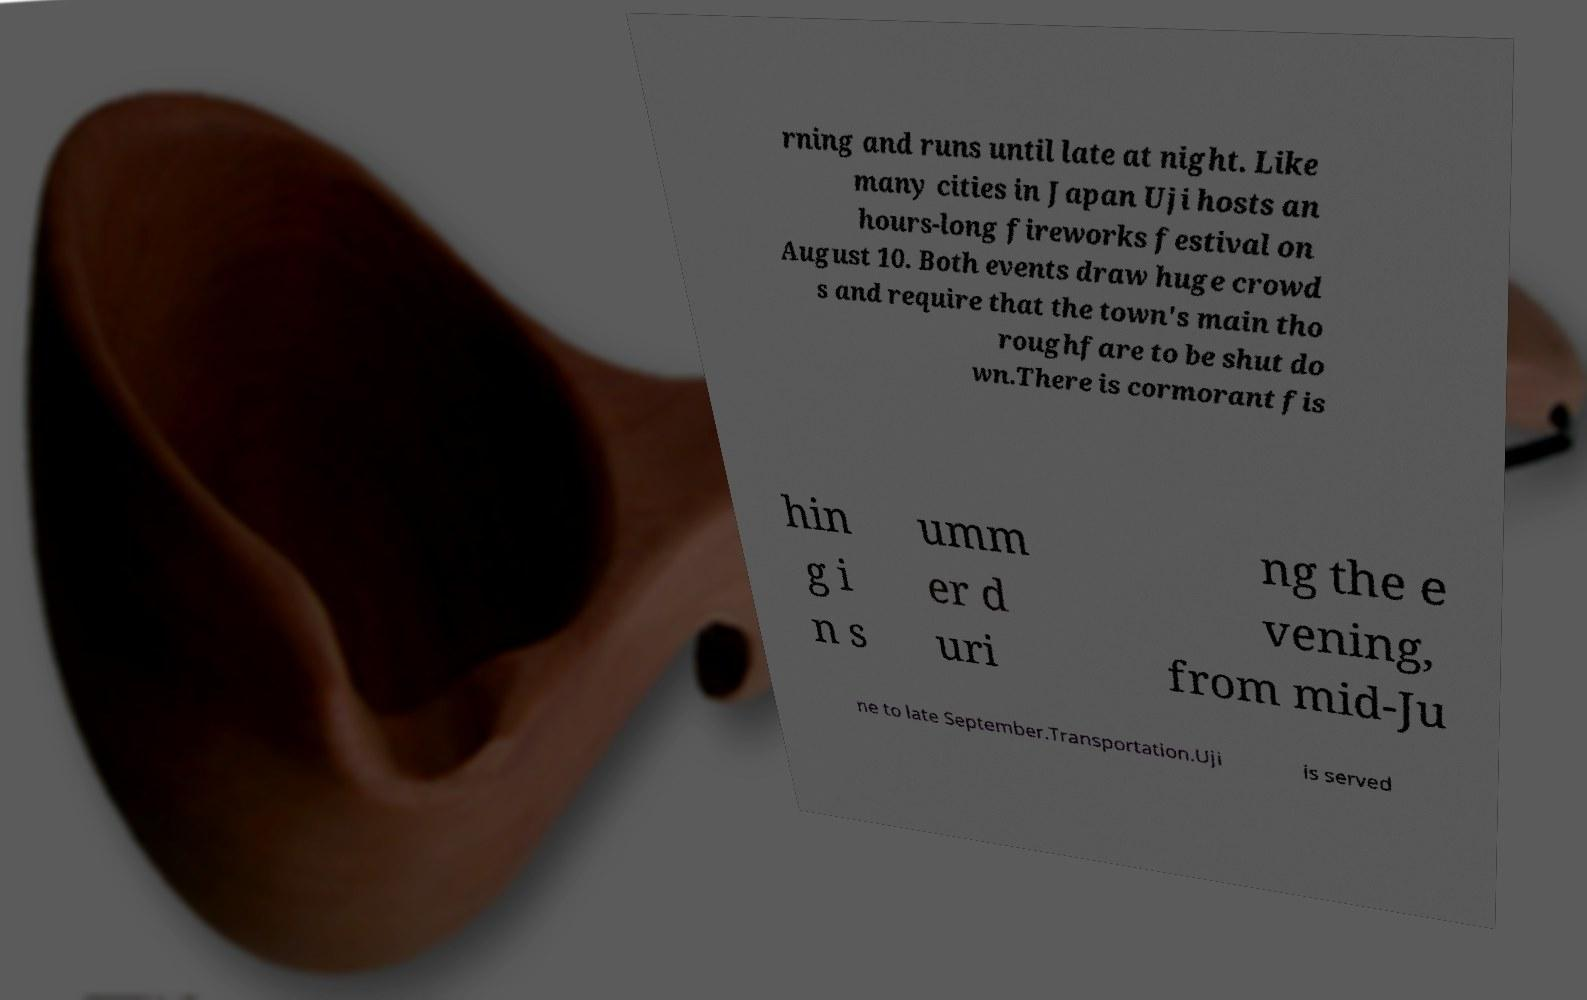Could you assist in decoding the text presented in this image and type it out clearly? rning and runs until late at night. Like many cities in Japan Uji hosts an hours-long fireworks festival on August 10. Both events draw huge crowd s and require that the town's main tho roughfare to be shut do wn.There is cormorant fis hin g i n s umm er d uri ng the e vening, from mid-Ju ne to late September.Transportation.Uji is served 